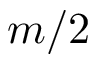<formula> <loc_0><loc_0><loc_500><loc_500>m / 2</formula> 